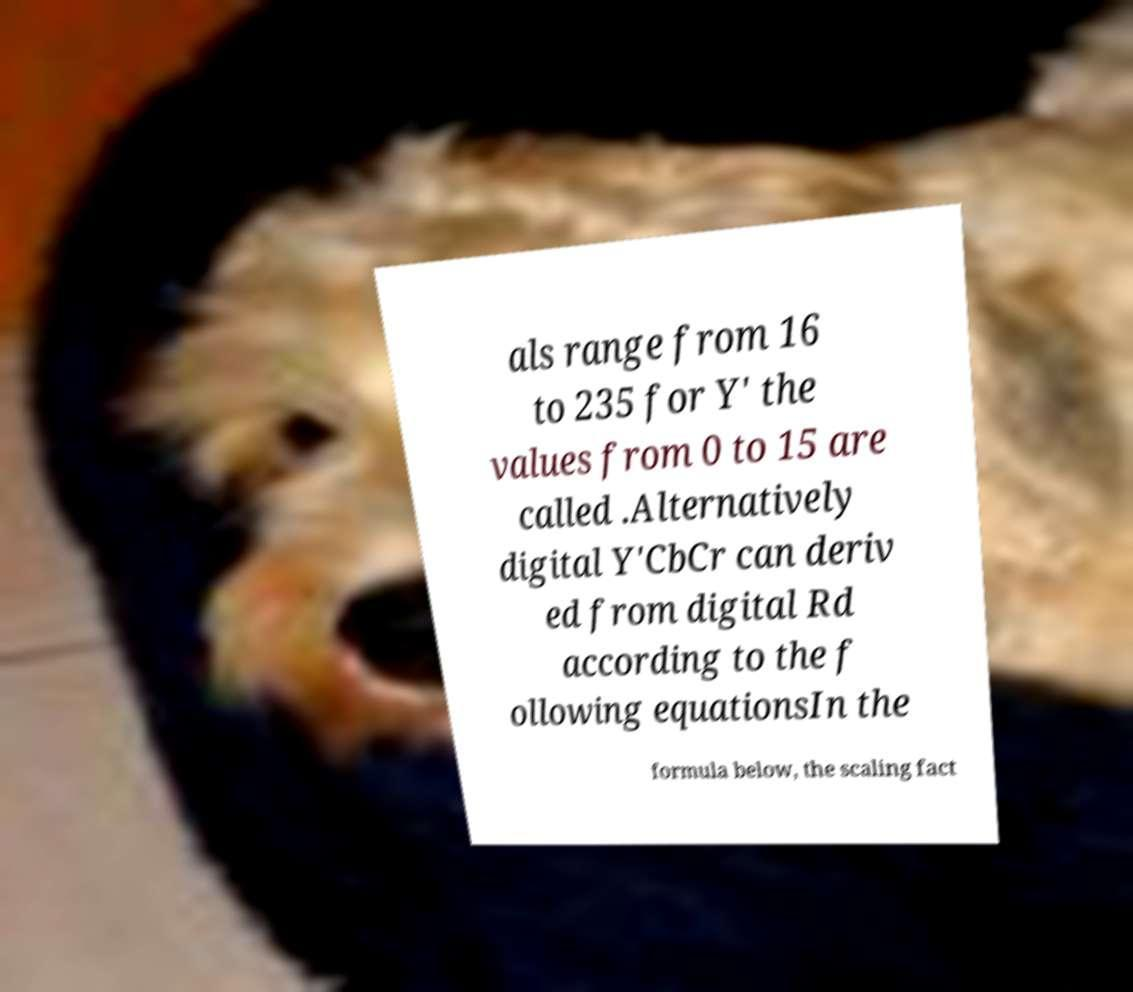What messages or text are displayed in this image? I need them in a readable, typed format. als range from 16 to 235 for Y′ the values from 0 to 15 are called .Alternatively digital Y′CbCr can deriv ed from digital Rd according to the f ollowing equationsIn the formula below, the scaling fact 